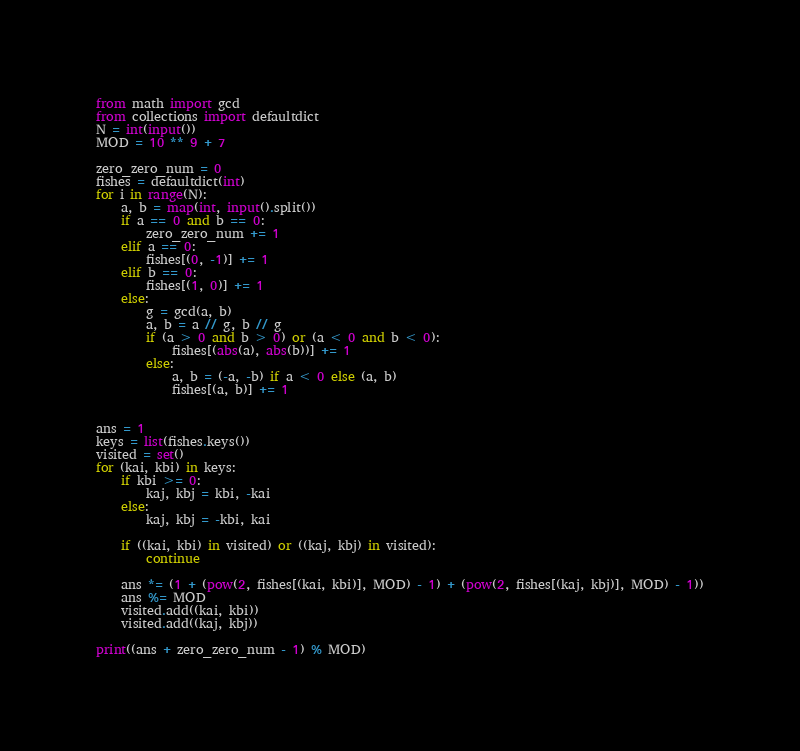Convert code to text. <code><loc_0><loc_0><loc_500><loc_500><_Python_>from math import gcd
from collections import defaultdict
N = int(input())
MOD = 10 ** 9 + 7

zero_zero_num = 0
fishes = defaultdict(int)
for i in range(N):
    a, b = map(int, input().split())
    if a == 0 and b == 0:
        zero_zero_num += 1
    elif a == 0:
        fishes[(0, -1)] += 1
    elif b == 0:
        fishes[(1, 0)] += 1
    else:
        g = gcd(a, b)
        a, b = a // g, b // g
        if (a > 0 and b > 0) or (a < 0 and b < 0):
            fishes[(abs(a), abs(b))] += 1
        else:
            a, b = (-a, -b) if a < 0 else (a, b)
            fishes[(a, b)] += 1


ans = 1
keys = list(fishes.keys())
visited = set()
for (kai, kbi) in keys:
    if kbi >= 0:
        kaj, kbj = kbi, -kai
    else:
        kaj, kbj = -kbi, kai

    if ((kai, kbi) in visited) or ((kaj, kbj) in visited):
        continue

    ans *= (1 + (pow(2, fishes[(kai, kbi)], MOD) - 1) + (pow(2, fishes[(kaj, kbj)], MOD) - 1))
    ans %= MOD
    visited.add((kai, kbi))
    visited.add((kaj, kbj))

print((ans + zero_zero_num - 1) % MOD)
</code> 